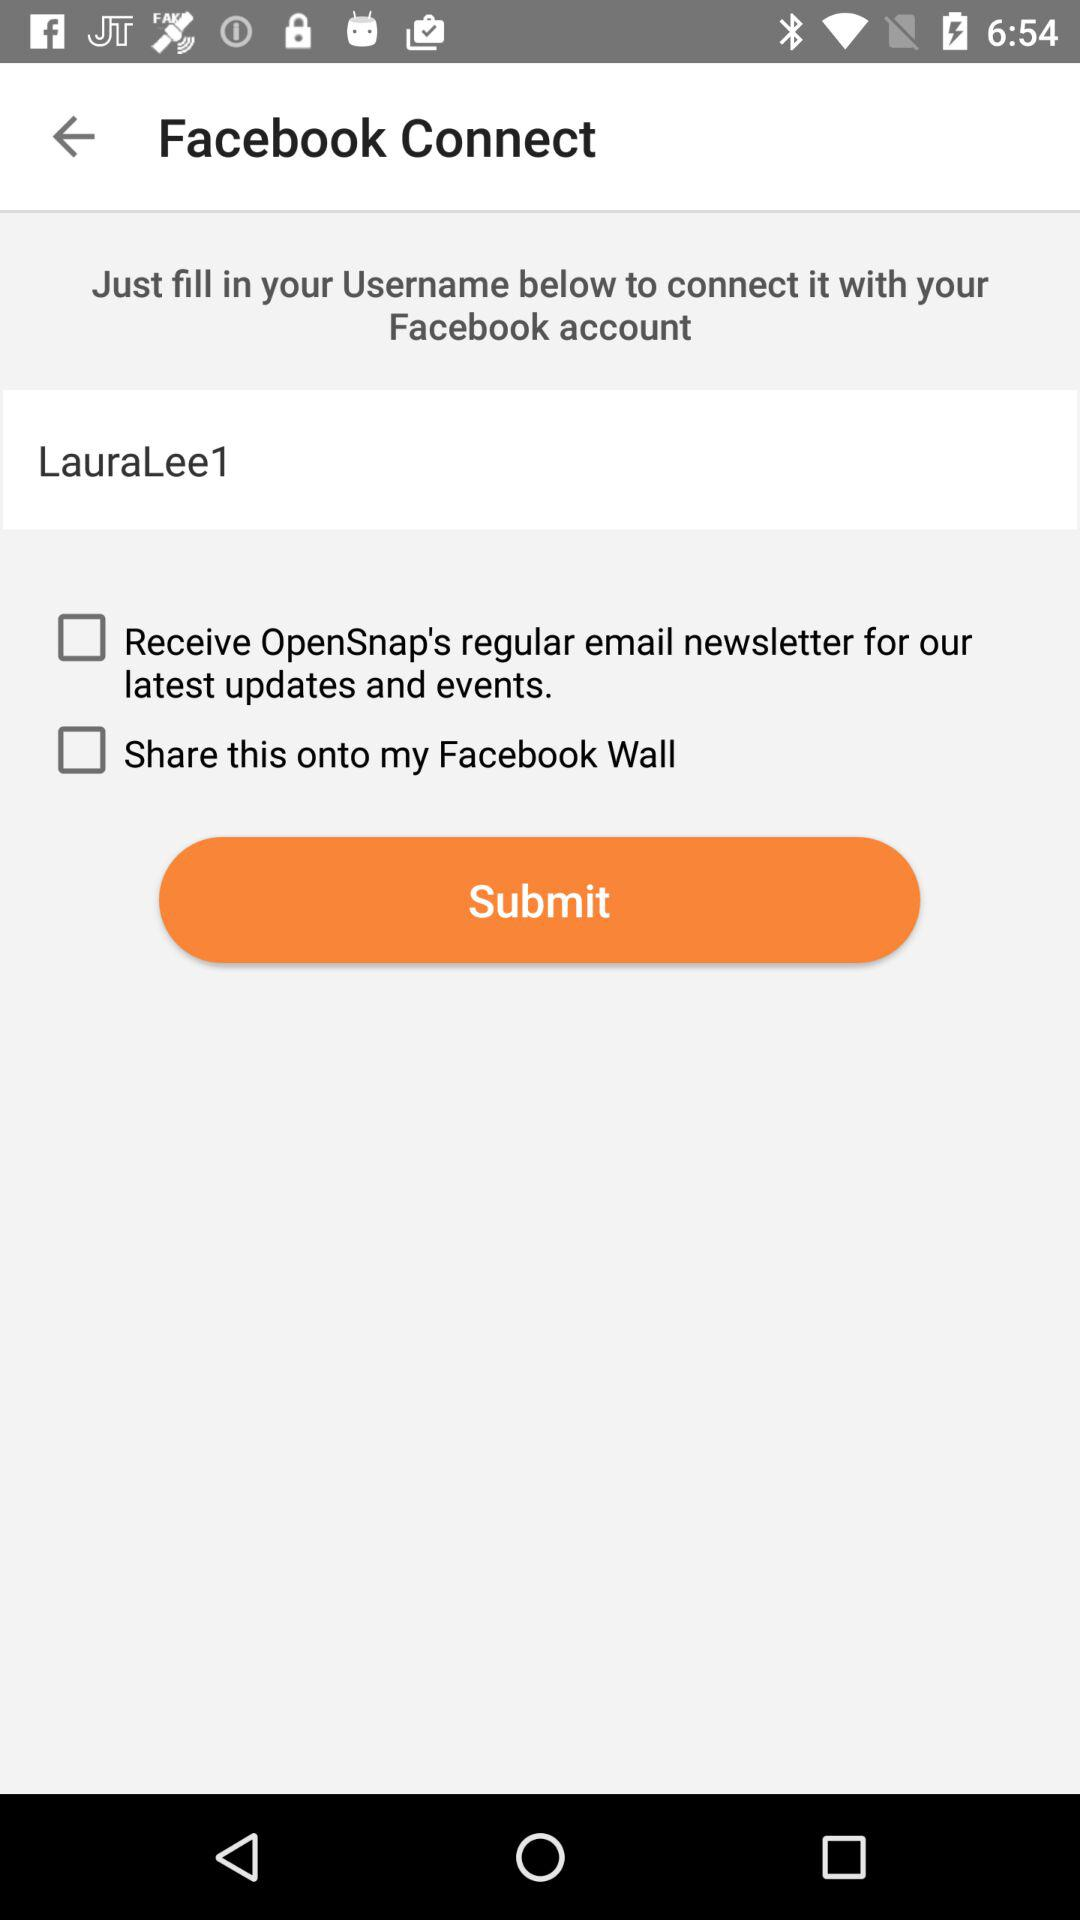What is the status of "Share this onto my Facebook Wall"? The status of "Share this onto my Facebook Wall" is "off". 